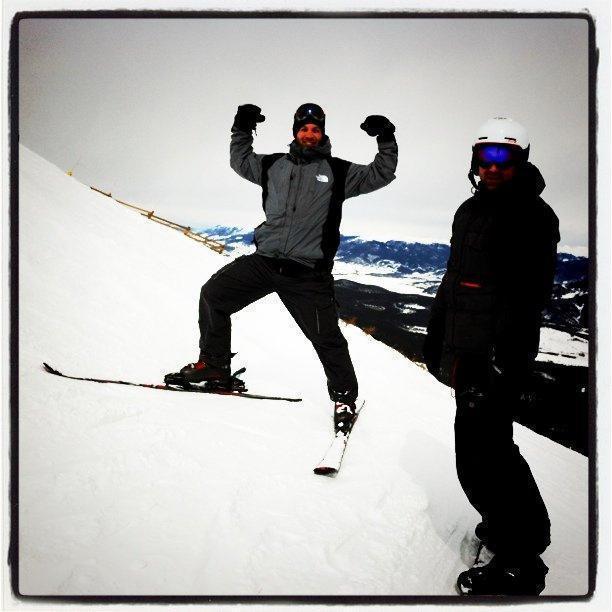What muscles in the male showing off?
Select the accurate response from the four choices given to answer the question.
Options: Biceps, deltas, triceps, quads. Biceps. 